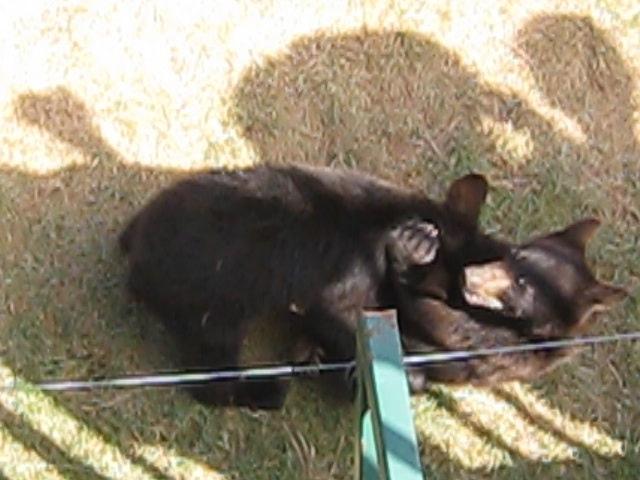How many ears can you see?
Give a very brief answer. 2. How many of these animals is alive?
Give a very brief answer. 2. 